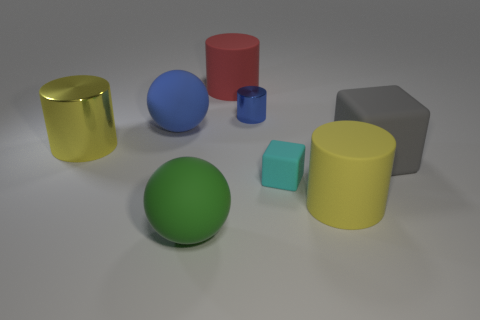Subtract 1 cylinders. How many cylinders are left? 3 Subtract all blue spheres. Subtract all purple cubes. How many spheres are left? 1 Add 1 yellow objects. How many objects exist? 9 Subtract all cubes. How many objects are left? 6 Subtract all green rubber objects. Subtract all red rubber cylinders. How many objects are left? 6 Add 3 cylinders. How many cylinders are left? 7 Add 2 cyan cubes. How many cyan cubes exist? 3 Subtract 0 gray spheres. How many objects are left? 8 